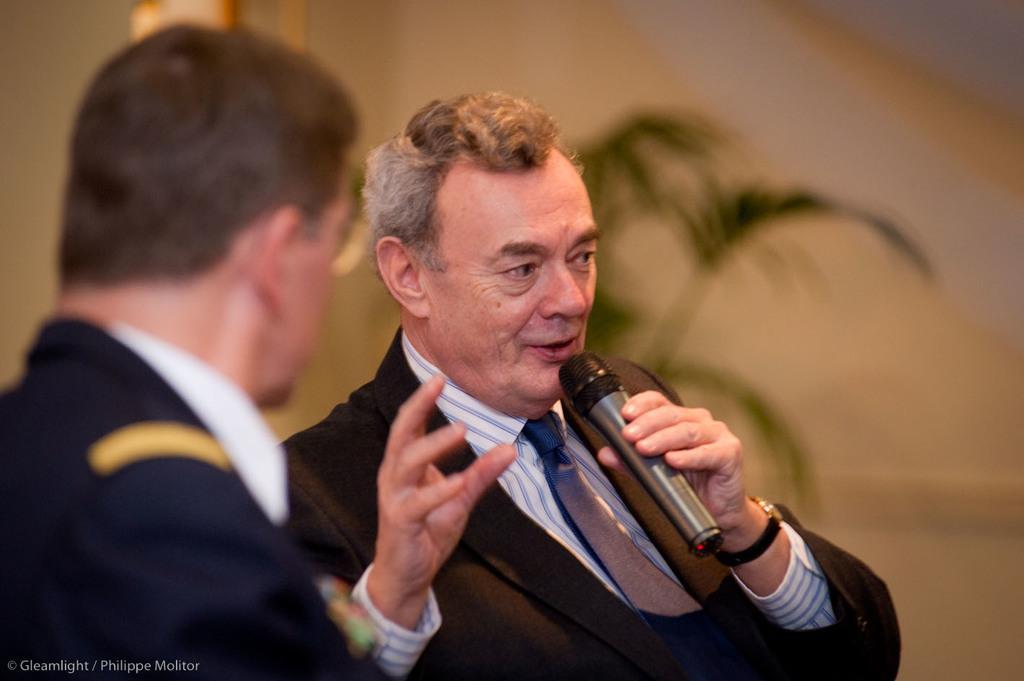Describe this image in one or two sentences. In this image there is a person holding a mike, there is another person , and in the background there is a plant and a watermark on the image. 